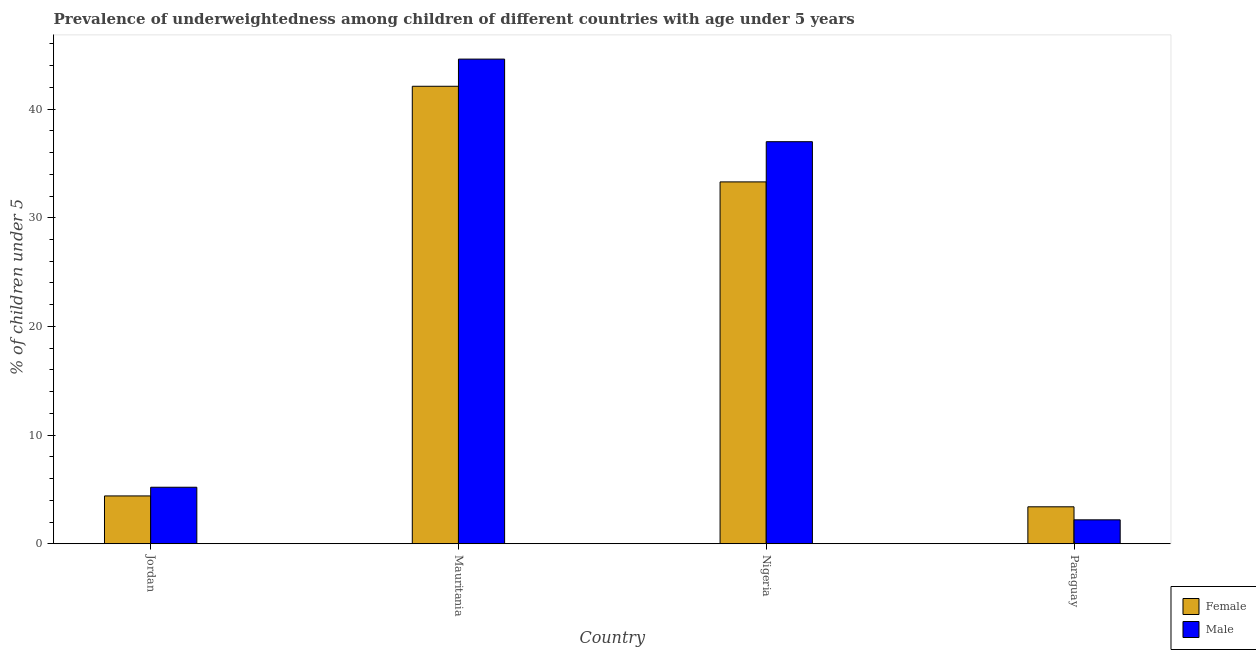How many groups of bars are there?
Offer a very short reply. 4. Are the number of bars per tick equal to the number of legend labels?
Offer a very short reply. Yes. What is the label of the 4th group of bars from the left?
Make the answer very short. Paraguay. In how many cases, is the number of bars for a given country not equal to the number of legend labels?
Provide a short and direct response. 0. What is the percentage of underweighted male children in Mauritania?
Your answer should be very brief. 44.6. Across all countries, what is the maximum percentage of underweighted male children?
Offer a terse response. 44.6. Across all countries, what is the minimum percentage of underweighted male children?
Offer a terse response. 2.2. In which country was the percentage of underweighted female children maximum?
Offer a terse response. Mauritania. In which country was the percentage of underweighted male children minimum?
Offer a terse response. Paraguay. What is the total percentage of underweighted male children in the graph?
Give a very brief answer. 89. What is the difference between the percentage of underweighted female children in Jordan and that in Nigeria?
Give a very brief answer. -28.9. What is the difference between the percentage of underweighted female children in Paraguay and the percentage of underweighted male children in Nigeria?
Provide a succinct answer. -33.6. What is the average percentage of underweighted male children per country?
Your answer should be very brief. 22.25. What is the difference between the percentage of underweighted male children and percentage of underweighted female children in Nigeria?
Your response must be concise. 3.7. In how many countries, is the percentage of underweighted female children greater than 38 %?
Offer a very short reply. 1. What is the ratio of the percentage of underweighted male children in Jordan to that in Nigeria?
Your answer should be compact. 0.14. What is the difference between the highest and the second highest percentage of underweighted male children?
Your response must be concise. 7.6. What is the difference between the highest and the lowest percentage of underweighted female children?
Provide a succinct answer. 38.7. In how many countries, is the percentage of underweighted female children greater than the average percentage of underweighted female children taken over all countries?
Your response must be concise. 2. What does the 1st bar from the right in Paraguay represents?
Ensure brevity in your answer.  Male. How many bars are there?
Your answer should be very brief. 8. Are all the bars in the graph horizontal?
Your answer should be compact. No. Are the values on the major ticks of Y-axis written in scientific E-notation?
Keep it short and to the point. No. Where does the legend appear in the graph?
Your answer should be compact. Bottom right. What is the title of the graph?
Provide a succinct answer. Prevalence of underweightedness among children of different countries with age under 5 years. What is the label or title of the Y-axis?
Ensure brevity in your answer.   % of children under 5. What is the  % of children under 5 of Female in Jordan?
Provide a short and direct response. 4.4. What is the  % of children under 5 of Male in Jordan?
Provide a succinct answer. 5.2. What is the  % of children under 5 of Female in Mauritania?
Offer a terse response. 42.1. What is the  % of children under 5 of Male in Mauritania?
Give a very brief answer. 44.6. What is the  % of children under 5 in Female in Nigeria?
Provide a short and direct response. 33.3. What is the  % of children under 5 of Female in Paraguay?
Your answer should be compact. 3.4. What is the  % of children under 5 in Male in Paraguay?
Provide a short and direct response. 2.2. Across all countries, what is the maximum  % of children under 5 in Female?
Keep it short and to the point. 42.1. Across all countries, what is the maximum  % of children under 5 of Male?
Offer a terse response. 44.6. Across all countries, what is the minimum  % of children under 5 of Female?
Offer a terse response. 3.4. Across all countries, what is the minimum  % of children under 5 of Male?
Provide a succinct answer. 2.2. What is the total  % of children under 5 in Female in the graph?
Ensure brevity in your answer.  83.2. What is the total  % of children under 5 in Male in the graph?
Offer a terse response. 89. What is the difference between the  % of children under 5 of Female in Jordan and that in Mauritania?
Your answer should be very brief. -37.7. What is the difference between the  % of children under 5 in Male in Jordan and that in Mauritania?
Offer a terse response. -39.4. What is the difference between the  % of children under 5 of Female in Jordan and that in Nigeria?
Your response must be concise. -28.9. What is the difference between the  % of children under 5 in Male in Jordan and that in Nigeria?
Your answer should be compact. -31.8. What is the difference between the  % of children under 5 of Male in Jordan and that in Paraguay?
Offer a very short reply. 3. What is the difference between the  % of children under 5 in Male in Mauritania and that in Nigeria?
Your response must be concise. 7.6. What is the difference between the  % of children under 5 in Female in Mauritania and that in Paraguay?
Give a very brief answer. 38.7. What is the difference between the  % of children under 5 in Male in Mauritania and that in Paraguay?
Make the answer very short. 42.4. What is the difference between the  % of children under 5 in Female in Nigeria and that in Paraguay?
Ensure brevity in your answer.  29.9. What is the difference between the  % of children under 5 in Male in Nigeria and that in Paraguay?
Provide a short and direct response. 34.8. What is the difference between the  % of children under 5 in Female in Jordan and the  % of children under 5 in Male in Mauritania?
Provide a succinct answer. -40.2. What is the difference between the  % of children under 5 in Female in Jordan and the  % of children under 5 in Male in Nigeria?
Your answer should be compact. -32.6. What is the difference between the  % of children under 5 of Female in Mauritania and the  % of children under 5 of Male in Nigeria?
Provide a short and direct response. 5.1. What is the difference between the  % of children under 5 in Female in Mauritania and the  % of children under 5 in Male in Paraguay?
Your answer should be compact. 39.9. What is the difference between the  % of children under 5 of Female in Nigeria and the  % of children under 5 of Male in Paraguay?
Ensure brevity in your answer.  31.1. What is the average  % of children under 5 of Female per country?
Keep it short and to the point. 20.8. What is the average  % of children under 5 of Male per country?
Offer a very short reply. 22.25. What is the difference between the  % of children under 5 of Female and  % of children under 5 of Male in Nigeria?
Your response must be concise. -3.7. What is the ratio of the  % of children under 5 of Female in Jordan to that in Mauritania?
Your response must be concise. 0.1. What is the ratio of the  % of children under 5 of Male in Jordan to that in Mauritania?
Provide a succinct answer. 0.12. What is the ratio of the  % of children under 5 of Female in Jordan to that in Nigeria?
Your answer should be compact. 0.13. What is the ratio of the  % of children under 5 in Male in Jordan to that in Nigeria?
Offer a very short reply. 0.14. What is the ratio of the  % of children under 5 of Female in Jordan to that in Paraguay?
Make the answer very short. 1.29. What is the ratio of the  % of children under 5 in Male in Jordan to that in Paraguay?
Keep it short and to the point. 2.36. What is the ratio of the  % of children under 5 of Female in Mauritania to that in Nigeria?
Provide a short and direct response. 1.26. What is the ratio of the  % of children under 5 of Male in Mauritania to that in Nigeria?
Your answer should be very brief. 1.21. What is the ratio of the  % of children under 5 of Female in Mauritania to that in Paraguay?
Ensure brevity in your answer.  12.38. What is the ratio of the  % of children under 5 of Male in Mauritania to that in Paraguay?
Provide a short and direct response. 20.27. What is the ratio of the  % of children under 5 in Female in Nigeria to that in Paraguay?
Offer a terse response. 9.79. What is the ratio of the  % of children under 5 of Male in Nigeria to that in Paraguay?
Make the answer very short. 16.82. What is the difference between the highest and the second highest  % of children under 5 of Female?
Provide a short and direct response. 8.8. What is the difference between the highest and the lowest  % of children under 5 in Female?
Provide a short and direct response. 38.7. What is the difference between the highest and the lowest  % of children under 5 of Male?
Your answer should be very brief. 42.4. 